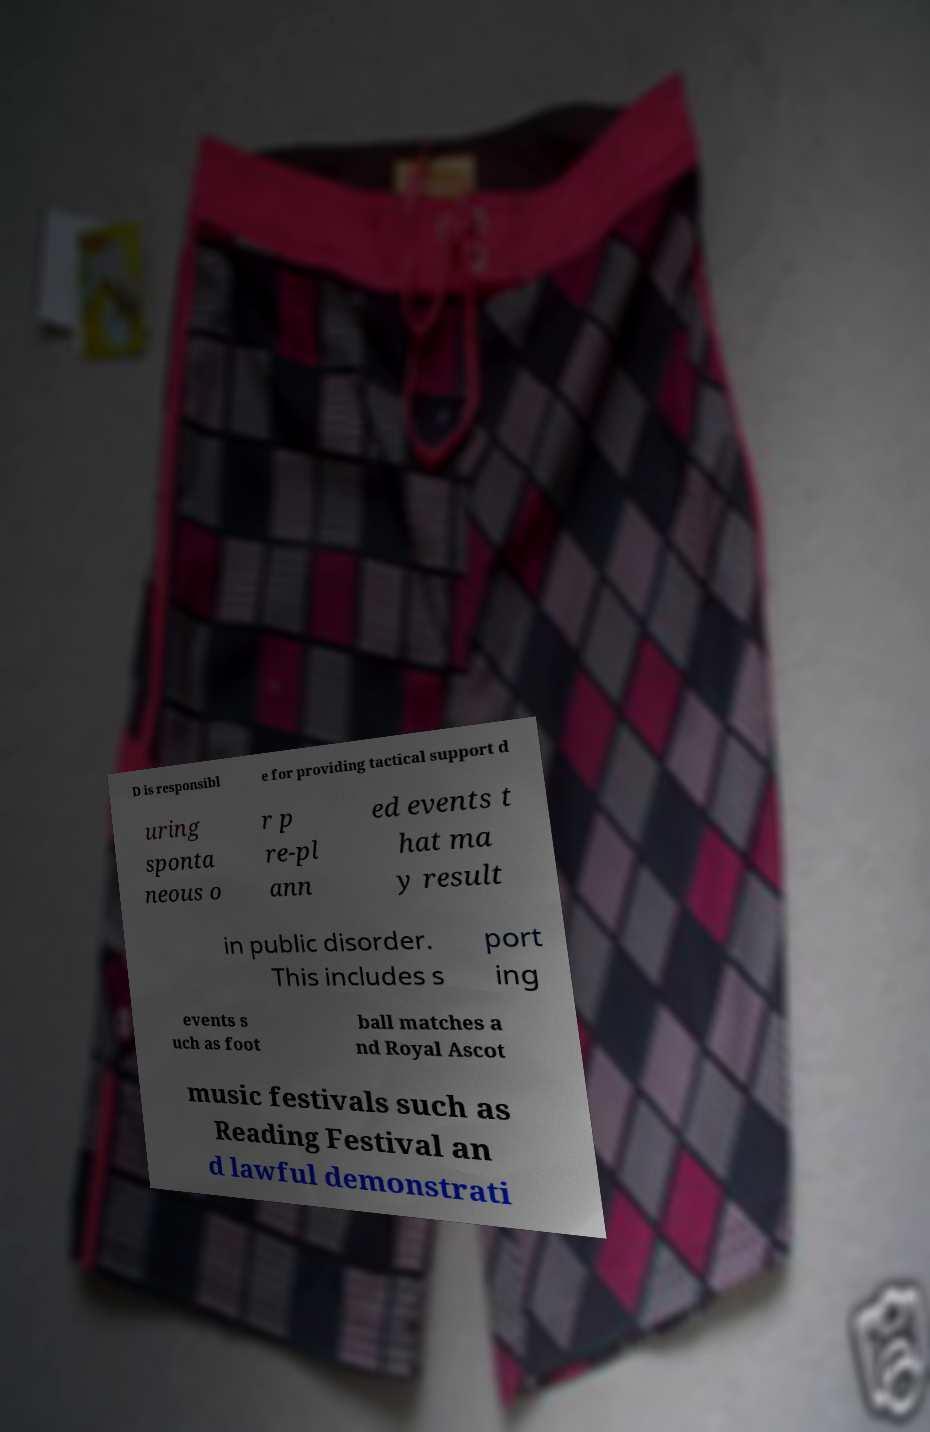For documentation purposes, I need the text within this image transcribed. Could you provide that? D is responsibl e for providing tactical support d uring sponta neous o r p re-pl ann ed events t hat ma y result in public disorder. This includes s port ing events s uch as foot ball matches a nd Royal Ascot music festivals such as Reading Festival an d lawful demonstrati 